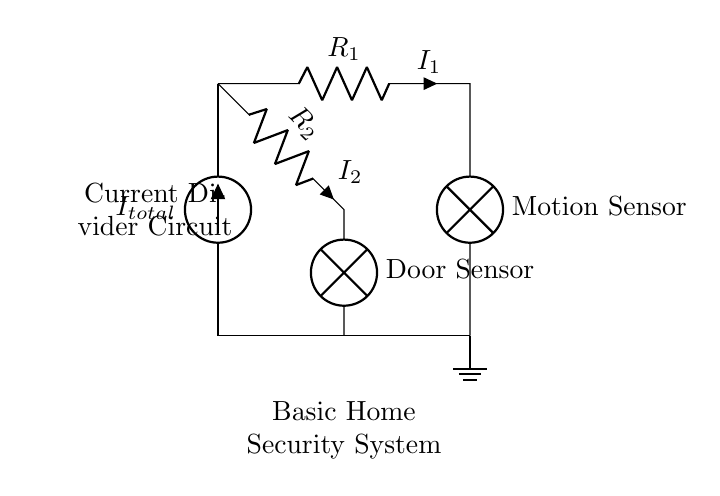What components are present in this circuit? The circuit includes a total current source, two resistors (R1 and R2), and two lamps (representing sensors). These components are connected to form a current divider.
Answer: total current source, two resistors, two lamps What is the purpose of the lamps in this circuit? The lamps represent the motion and door sensors in the home security system. They indicate if the respective sensors are activated by current flow.
Answer: sensors What is the relationship between the current I1 and I2? I1 and I2 are related by the current divider rule, which states that the total current I_total splits into I1 and I2 in proportion to the resistances R1 and R2. Thus, I1 = I_total * (R2 / (R1 + R2)) and I2 = I_total * (R1 / (R1 + R2)).
Answer: I1 and I2 are proportional to R2 and R1 respectively What happens to the current through the sensors when R1 decreases? If R1 decreases, the resistance of branch 1 is smaller, which will increase the current I1 through the motion sensor (lamp), following the current divider rule. Conversely, I2 decreases.
Answer: I1 increases, I2 decreases How does the total current affect the operation of the door sensor? The total current I_total determines the amount of current that will pass through both branches. More I_total will mean higher current for I2, making the door sensor more responsive. If I_total is low, I2 may not be sufficient to activate the sensor.
Answer: Higher I_total increases I2 What is the total current in the circuit if R1 is 10 ohms and R2 is 20 ohms with I1 equal to 2 amperes? Using the current divider formula I1 = I_total * (R2 / (R1 + R2)), we can find I_total: I_total = I1 * (R1 + R2) / R2 = 2 * (10 + 20) / 20 = 3 amperes.
Answer: 3 amperes 